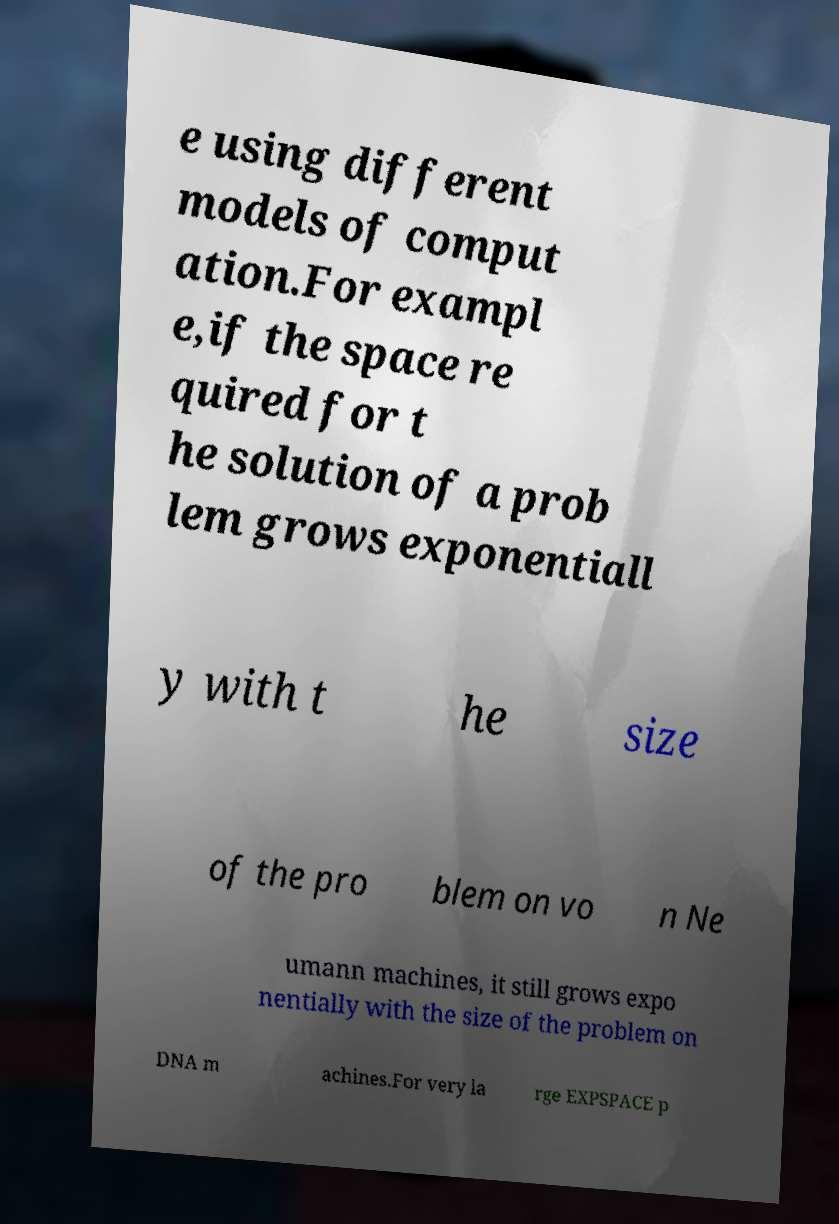Could you assist in decoding the text presented in this image and type it out clearly? e using different models of comput ation.For exampl e,if the space re quired for t he solution of a prob lem grows exponentiall y with t he size of the pro blem on vo n Ne umann machines, it still grows expo nentially with the size of the problem on DNA m achines.For very la rge EXPSPACE p 